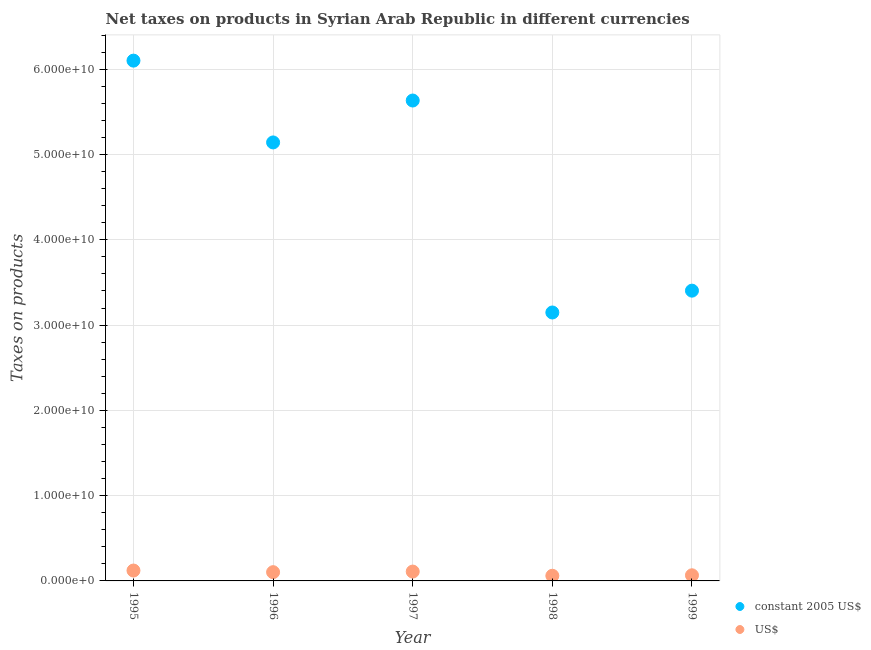Is the number of dotlines equal to the number of legend labels?
Your answer should be compact. Yes. What is the net taxes in constant 2005 us$ in 1997?
Provide a succinct answer. 5.63e+1. Across all years, what is the maximum net taxes in us$?
Keep it short and to the point. 1.22e+09. Across all years, what is the minimum net taxes in constant 2005 us$?
Keep it short and to the point. 3.15e+1. In which year was the net taxes in constant 2005 us$ maximum?
Keep it short and to the point. 1995. In which year was the net taxes in constant 2005 us$ minimum?
Offer a very short reply. 1998. What is the total net taxes in us$ in the graph?
Provide a short and direct response. 4.60e+09. What is the difference between the net taxes in constant 2005 us$ in 1998 and that in 1999?
Keep it short and to the point. -2.56e+09. What is the difference between the net taxes in us$ in 1997 and the net taxes in constant 2005 us$ in 1996?
Offer a very short reply. -5.03e+1. What is the average net taxes in us$ per year?
Give a very brief answer. 9.21e+08. In the year 1999, what is the difference between the net taxes in constant 2005 us$ and net taxes in us$?
Keep it short and to the point. 3.34e+1. In how many years, is the net taxes in constant 2005 us$ greater than 12000000000 units?
Provide a succinct answer. 5. What is the ratio of the net taxes in us$ in 1995 to that in 1996?
Offer a terse response. 1.19. Is the net taxes in constant 2005 us$ in 1996 less than that in 1998?
Keep it short and to the point. No. Is the difference between the net taxes in constant 2005 us$ in 1997 and 1999 greater than the difference between the net taxes in us$ in 1997 and 1999?
Provide a succinct answer. Yes. What is the difference between the highest and the second highest net taxes in constant 2005 us$?
Offer a very short reply. 4.68e+09. What is the difference between the highest and the lowest net taxes in us$?
Your answer should be very brief. 6.12e+08. Is the net taxes in constant 2005 us$ strictly less than the net taxes in us$ over the years?
Provide a succinct answer. No. How many dotlines are there?
Your answer should be very brief. 2. Are the values on the major ticks of Y-axis written in scientific E-notation?
Offer a very short reply. Yes. Where does the legend appear in the graph?
Ensure brevity in your answer.  Bottom right. What is the title of the graph?
Keep it short and to the point. Net taxes on products in Syrian Arab Republic in different currencies. Does "Foreign Liabilities" appear as one of the legend labels in the graph?
Provide a short and direct response. No. What is the label or title of the X-axis?
Give a very brief answer. Year. What is the label or title of the Y-axis?
Keep it short and to the point. Taxes on products. What is the Taxes on products of constant 2005 US$ in 1995?
Make the answer very short. 6.10e+1. What is the Taxes on products of US$ in 1995?
Your response must be concise. 1.22e+09. What is the Taxes on products of constant 2005 US$ in 1996?
Your answer should be very brief. 5.14e+1. What is the Taxes on products in US$ in 1996?
Offer a terse response. 1.03e+09. What is the Taxes on products in constant 2005 US$ in 1997?
Your answer should be compact. 5.63e+1. What is the Taxes on products of US$ in 1997?
Your answer should be very brief. 1.10e+09. What is the Taxes on products of constant 2005 US$ in 1998?
Offer a terse response. 3.15e+1. What is the Taxes on products in US$ in 1998?
Your answer should be very brief. 6.05e+08. What is the Taxes on products of constant 2005 US$ in 1999?
Give a very brief answer. 3.40e+1. What is the Taxes on products in US$ in 1999?
Offer a very short reply. 6.60e+08. Across all years, what is the maximum Taxes on products of constant 2005 US$?
Offer a very short reply. 6.10e+1. Across all years, what is the maximum Taxes on products in US$?
Give a very brief answer. 1.22e+09. Across all years, what is the minimum Taxes on products in constant 2005 US$?
Keep it short and to the point. 3.15e+1. Across all years, what is the minimum Taxes on products of US$?
Offer a very short reply. 6.05e+08. What is the total Taxes on products of constant 2005 US$ in the graph?
Make the answer very short. 2.34e+11. What is the total Taxes on products in US$ in the graph?
Ensure brevity in your answer.  4.60e+09. What is the difference between the Taxes on products of constant 2005 US$ in 1995 and that in 1996?
Give a very brief answer. 9.59e+09. What is the difference between the Taxes on products in US$ in 1995 and that in 1996?
Offer a terse response. 1.91e+08. What is the difference between the Taxes on products in constant 2005 US$ in 1995 and that in 1997?
Offer a very short reply. 4.68e+09. What is the difference between the Taxes on products in US$ in 1995 and that in 1997?
Your answer should be very brief. 1.22e+08. What is the difference between the Taxes on products in constant 2005 US$ in 1995 and that in 1998?
Provide a succinct answer. 2.95e+1. What is the difference between the Taxes on products in US$ in 1995 and that in 1998?
Ensure brevity in your answer.  6.12e+08. What is the difference between the Taxes on products in constant 2005 US$ in 1995 and that in 1999?
Keep it short and to the point. 2.70e+1. What is the difference between the Taxes on products of US$ in 1995 and that in 1999?
Offer a terse response. 5.58e+08. What is the difference between the Taxes on products in constant 2005 US$ in 1996 and that in 1997?
Keep it short and to the point. -4.91e+09. What is the difference between the Taxes on products in US$ in 1996 and that in 1997?
Offer a terse response. -6.96e+07. What is the difference between the Taxes on products in constant 2005 US$ in 1996 and that in 1998?
Ensure brevity in your answer.  1.99e+1. What is the difference between the Taxes on products in US$ in 1996 and that in 1998?
Keep it short and to the point. 4.21e+08. What is the difference between the Taxes on products of constant 2005 US$ in 1996 and that in 1999?
Your answer should be compact. 1.74e+1. What is the difference between the Taxes on products in US$ in 1996 and that in 1999?
Keep it short and to the point. 3.67e+08. What is the difference between the Taxes on products of constant 2005 US$ in 1997 and that in 1998?
Provide a succinct answer. 2.49e+1. What is the difference between the Taxes on products of US$ in 1997 and that in 1998?
Keep it short and to the point. 4.91e+08. What is the difference between the Taxes on products of constant 2005 US$ in 1997 and that in 1999?
Offer a terse response. 2.23e+1. What is the difference between the Taxes on products of US$ in 1997 and that in 1999?
Ensure brevity in your answer.  4.36e+08. What is the difference between the Taxes on products in constant 2005 US$ in 1998 and that in 1999?
Your response must be concise. -2.56e+09. What is the difference between the Taxes on products in US$ in 1998 and that in 1999?
Your response must be concise. -5.43e+07. What is the difference between the Taxes on products in constant 2005 US$ in 1995 and the Taxes on products in US$ in 1996?
Make the answer very short. 6.00e+1. What is the difference between the Taxes on products of constant 2005 US$ in 1995 and the Taxes on products of US$ in 1997?
Ensure brevity in your answer.  5.99e+1. What is the difference between the Taxes on products of constant 2005 US$ in 1995 and the Taxes on products of US$ in 1998?
Offer a very short reply. 6.04e+1. What is the difference between the Taxes on products in constant 2005 US$ in 1995 and the Taxes on products in US$ in 1999?
Offer a terse response. 6.03e+1. What is the difference between the Taxes on products in constant 2005 US$ in 1996 and the Taxes on products in US$ in 1997?
Offer a terse response. 5.03e+1. What is the difference between the Taxes on products in constant 2005 US$ in 1996 and the Taxes on products in US$ in 1998?
Give a very brief answer. 5.08e+1. What is the difference between the Taxes on products of constant 2005 US$ in 1996 and the Taxes on products of US$ in 1999?
Provide a short and direct response. 5.08e+1. What is the difference between the Taxes on products of constant 2005 US$ in 1997 and the Taxes on products of US$ in 1998?
Provide a succinct answer. 5.57e+1. What is the difference between the Taxes on products in constant 2005 US$ in 1997 and the Taxes on products in US$ in 1999?
Provide a succinct answer. 5.57e+1. What is the difference between the Taxes on products of constant 2005 US$ in 1998 and the Taxes on products of US$ in 1999?
Make the answer very short. 3.08e+1. What is the average Taxes on products of constant 2005 US$ per year?
Your response must be concise. 4.69e+1. What is the average Taxes on products in US$ per year?
Ensure brevity in your answer.  9.21e+08. In the year 1995, what is the difference between the Taxes on products in constant 2005 US$ and Taxes on products in US$?
Offer a very short reply. 5.98e+1. In the year 1996, what is the difference between the Taxes on products of constant 2005 US$ and Taxes on products of US$?
Give a very brief answer. 5.04e+1. In the year 1997, what is the difference between the Taxes on products in constant 2005 US$ and Taxes on products in US$?
Provide a succinct answer. 5.52e+1. In the year 1998, what is the difference between the Taxes on products of constant 2005 US$ and Taxes on products of US$?
Ensure brevity in your answer.  3.09e+1. In the year 1999, what is the difference between the Taxes on products of constant 2005 US$ and Taxes on products of US$?
Ensure brevity in your answer.  3.34e+1. What is the ratio of the Taxes on products of constant 2005 US$ in 1995 to that in 1996?
Your response must be concise. 1.19. What is the ratio of the Taxes on products of US$ in 1995 to that in 1996?
Provide a succinct answer. 1.19. What is the ratio of the Taxes on products of constant 2005 US$ in 1995 to that in 1997?
Offer a very short reply. 1.08. What is the ratio of the Taxes on products in US$ in 1995 to that in 1997?
Keep it short and to the point. 1.11. What is the ratio of the Taxes on products of constant 2005 US$ in 1995 to that in 1998?
Your answer should be compact. 1.94. What is the ratio of the Taxes on products in US$ in 1995 to that in 1998?
Provide a short and direct response. 2.01. What is the ratio of the Taxes on products in constant 2005 US$ in 1995 to that in 1999?
Keep it short and to the point. 1.79. What is the ratio of the Taxes on products in US$ in 1995 to that in 1999?
Your answer should be very brief. 1.85. What is the ratio of the Taxes on products in constant 2005 US$ in 1996 to that in 1997?
Provide a short and direct response. 0.91. What is the ratio of the Taxes on products of US$ in 1996 to that in 1997?
Keep it short and to the point. 0.94. What is the ratio of the Taxes on products of constant 2005 US$ in 1996 to that in 1998?
Make the answer very short. 1.63. What is the ratio of the Taxes on products of US$ in 1996 to that in 1998?
Make the answer very short. 1.7. What is the ratio of the Taxes on products in constant 2005 US$ in 1996 to that in 1999?
Your answer should be compact. 1.51. What is the ratio of the Taxes on products of US$ in 1996 to that in 1999?
Your response must be concise. 1.56. What is the ratio of the Taxes on products of constant 2005 US$ in 1997 to that in 1998?
Keep it short and to the point. 1.79. What is the ratio of the Taxes on products in US$ in 1997 to that in 1998?
Offer a terse response. 1.81. What is the ratio of the Taxes on products in constant 2005 US$ in 1997 to that in 1999?
Keep it short and to the point. 1.66. What is the ratio of the Taxes on products in US$ in 1997 to that in 1999?
Keep it short and to the point. 1.66. What is the ratio of the Taxes on products of constant 2005 US$ in 1998 to that in 1999?
Provide a short and direct response. 0.92. What is the ratio of the Taxes on products of US$ in 1998 to that in 1999?
Provide a succinct answer. 0.92. What is the difference between the highest and the second highest Taxes on products in constant 2005 US$?
Provide a short and direct response. 4.68e+09. What is the difference between the highest and the second highest Taxes on products in US$?
Provide a short and direct response. 1.22e+08. What is the difference between the highest and the lowest Taxes on products of constant 2005 US$?
Keep it short and to the point. 2.95e+1. What is the difference between the highest and the lowest Taxes on products of US$?
Make the answer very short. 6.12e+08. 